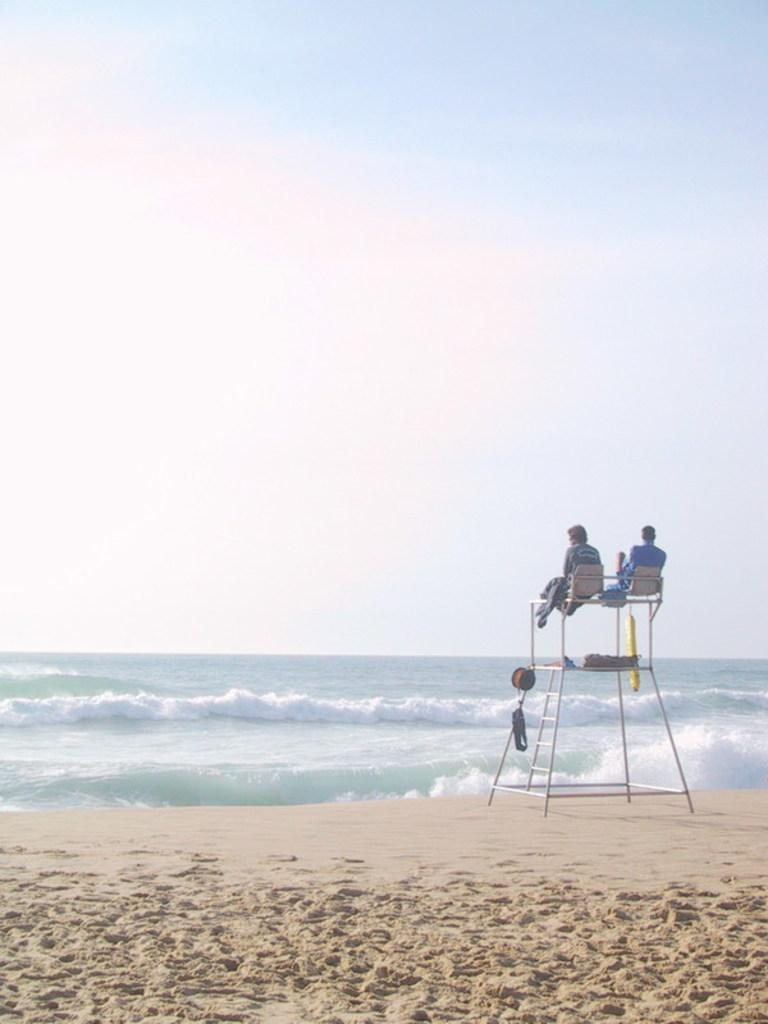How many people are sitting on the stand in the image? There are two members sitting on the stand in the image. Where is the stand located? The stand is located on a beach. What can be seen in the background of the image? There is an ocean and the sky visible in the background of the image. What type of locket is hanging from the neck of one of the members on the stand? There is no locket visible on any of the members in the image. Can you describe the curve of the ocean waves in the background? The image does not provide enough detail to describe the curve of the ocean waves. 